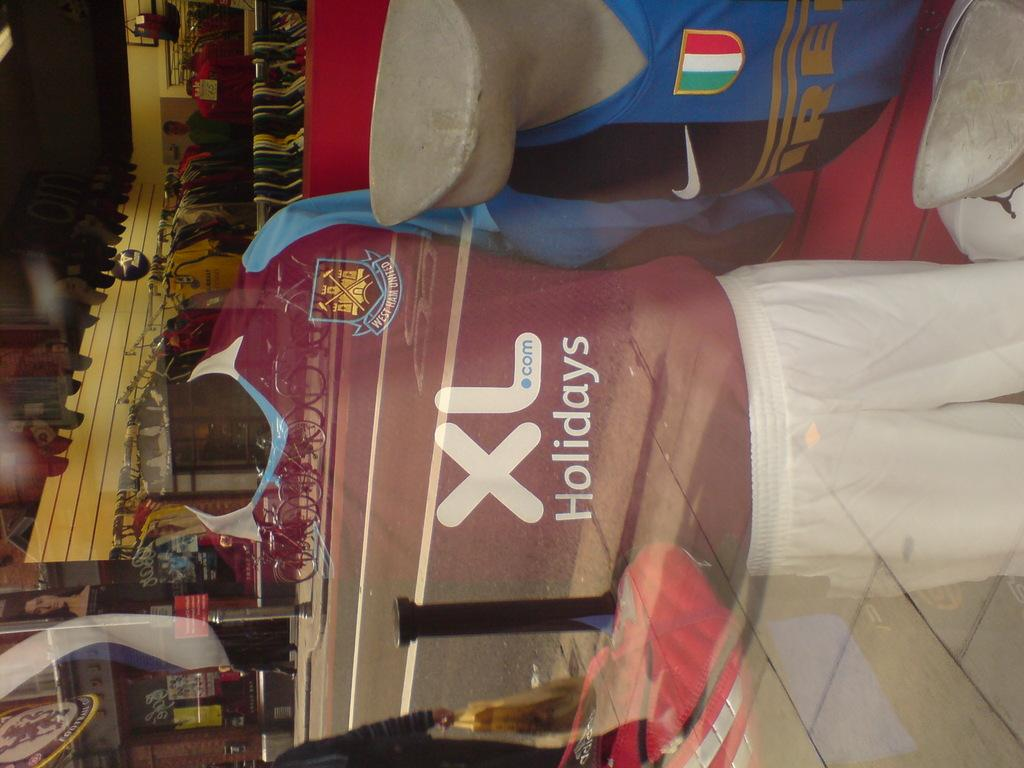How many mannequins are in the image? There are two mannequins in the image. What are the mannequins wearing? The mannequins are wearing dresses. What can be seen on the glass in the image? The reflection of the road and bicycles is visible on the glass. What else is present in the image besides the mannequins and glass? There are objects visible in the image. What type of airplane is visible in the form of a reflection on the glass? There is no airplane visible in the image, let alone a reflection of one on the glass. 